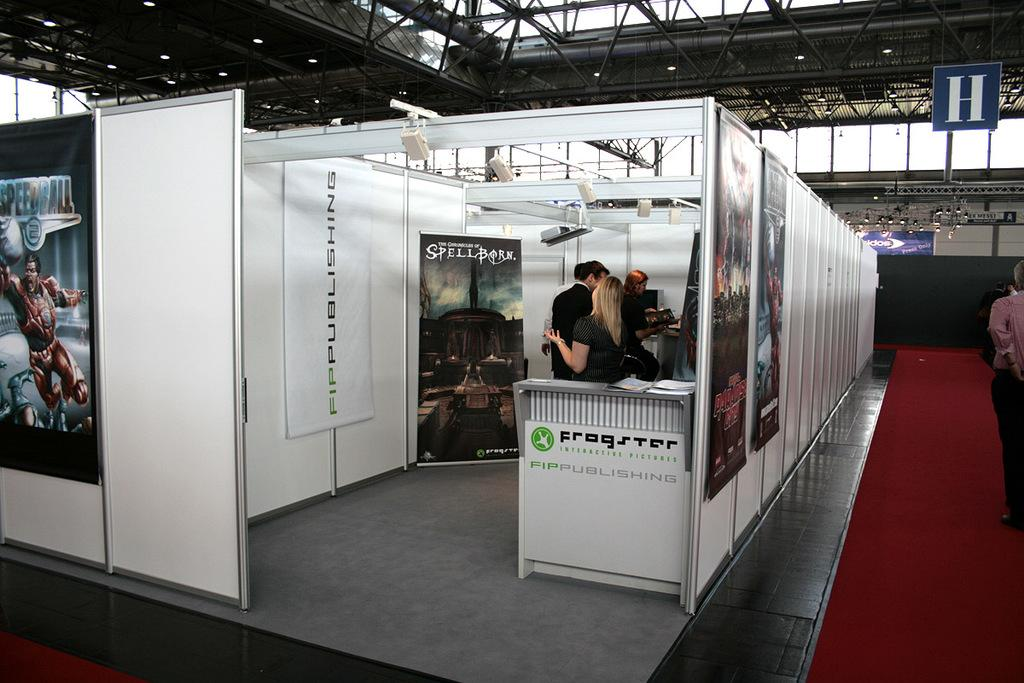How many people are in the image? There are persons in the image, but the exact number cannot be determined from the provided facts. What is the color of the object in the image? There is a white color object in the image. How many eyes does the snail have in the image? There is no snail present in the image, so it is not possible to determine the number of eyes it might have. 